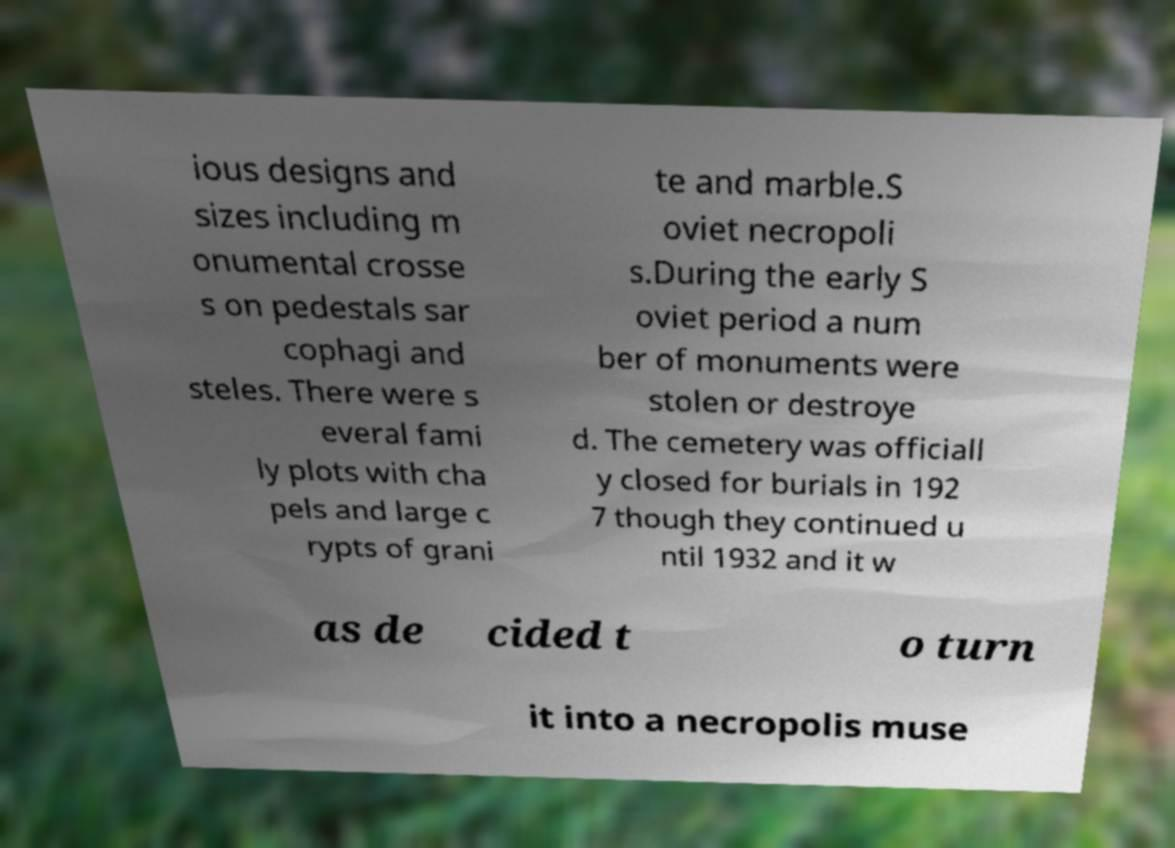Please identify and transcribe the text found in this image. ious designs and sizes including m onumental crosse s on pedestals sar cophagi and steles. There were s everal fami ly plots with cha pels and large c rypts of grani te and marble.S oviet necropoli s.During the early S oviet period a num ber of monuments were stolen or destroye d. The cemetery was officiall y closed for burials in 192 7 though they continued u ntil 1932 and it w as de cided t o turn it into a necropolis muse 